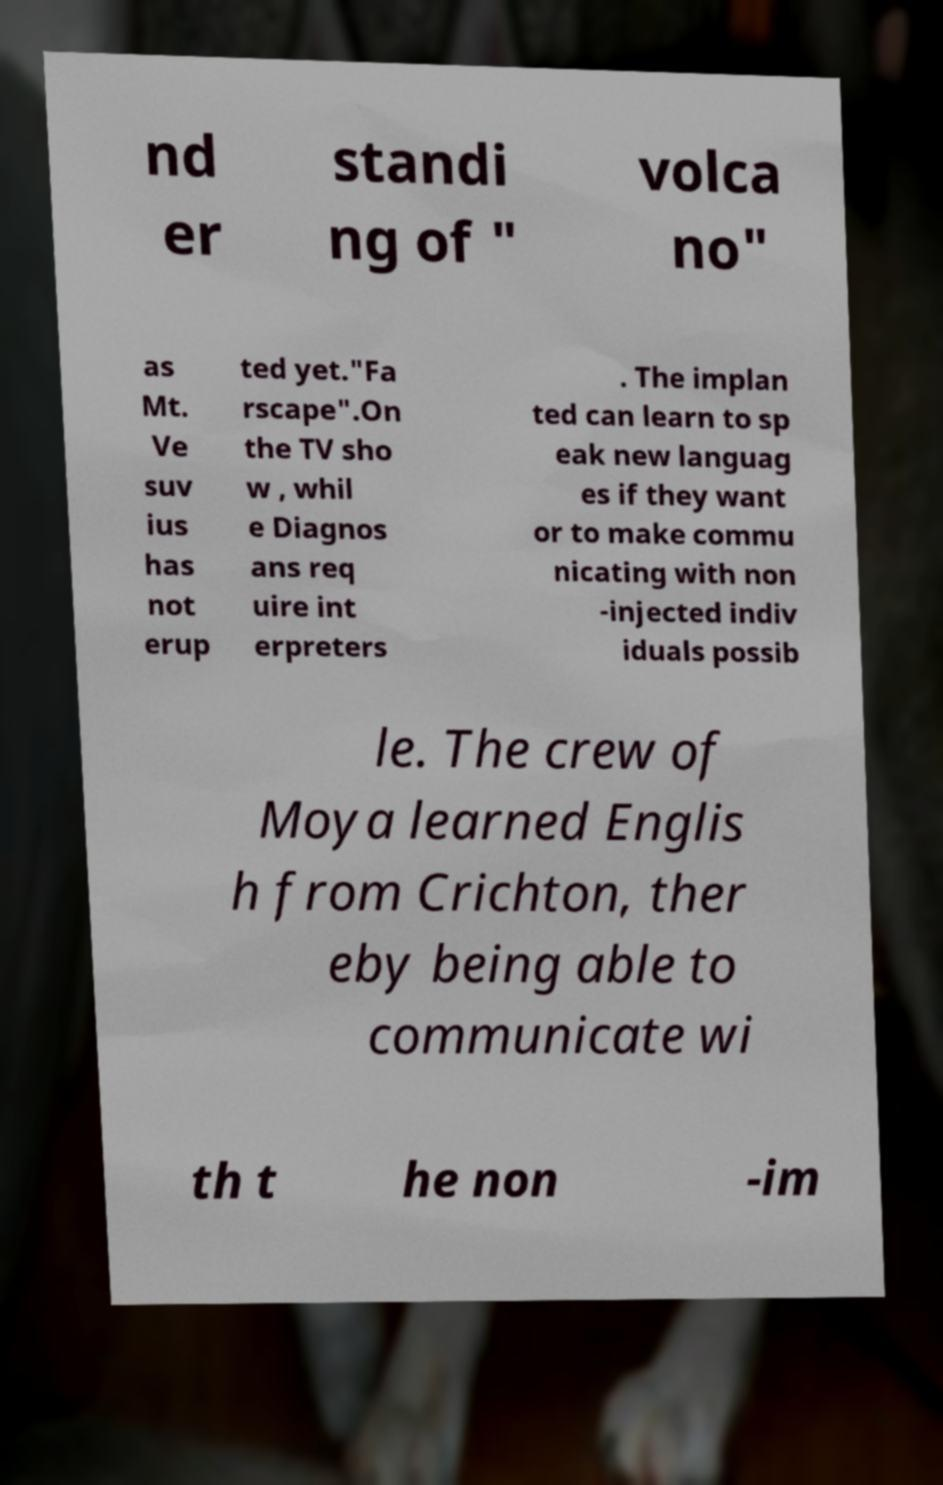There's text embedded in this image that I need extracted. Can you transcribe it verbatim? nd er standi ng of " volca no" as Mt. Ve suv ius has not erup ted yet."Fa rscape".On the TV sho w , whil e Diagnos ans req uire int erpreters . The implan ted can learn to sp eak new languag es if they want or to make commu nicating with non -injected indiv iduals possib le. The crew of Moya learned Englis h from Crichton, ther eby being able to communicate wi th t he non -im 